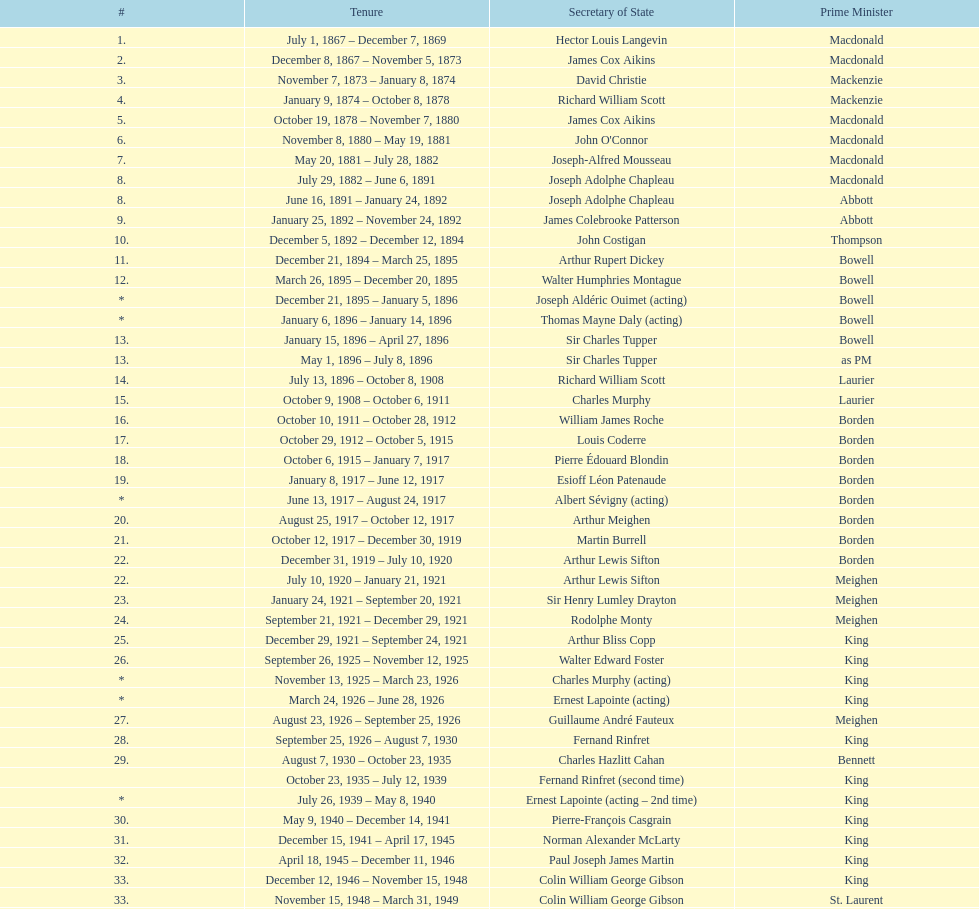How many secretaries of state had the last name bouchard? 2. 